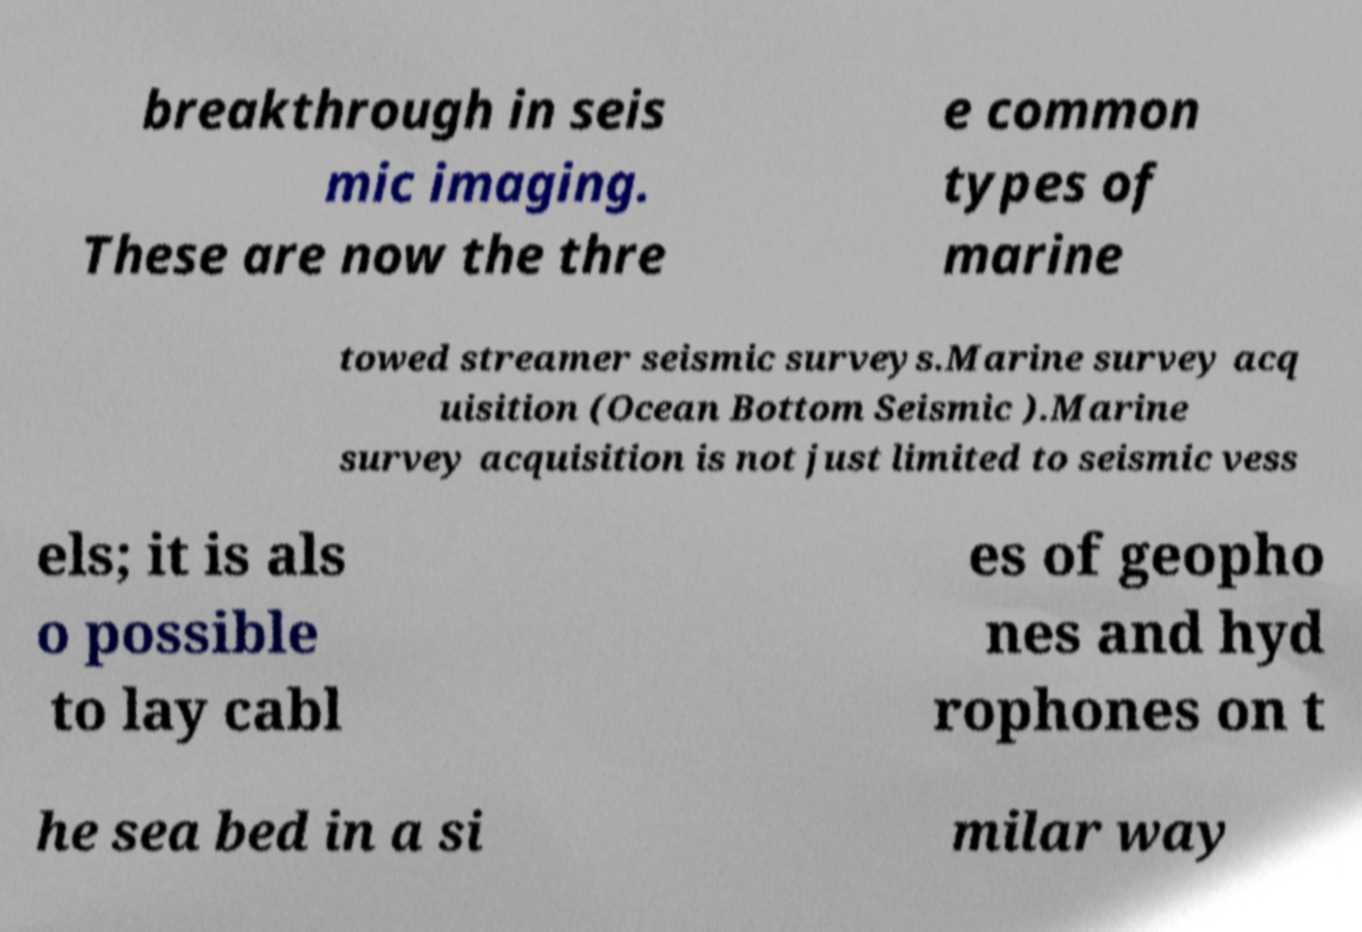Could you assist in decoding the text presented in this image and type it out clearly? breakthrough in seis mic imaging. These are now the thre e common types of marine towed streamer seismic surveys.Marine survey acq uisition (Ocean Bottom Seismic ).Marine survey acquisition is not just limited to seismic vess els; it is als o possible to lay cabl es of geopho nes and hyd rophones on t he sea bed in a si milar way 